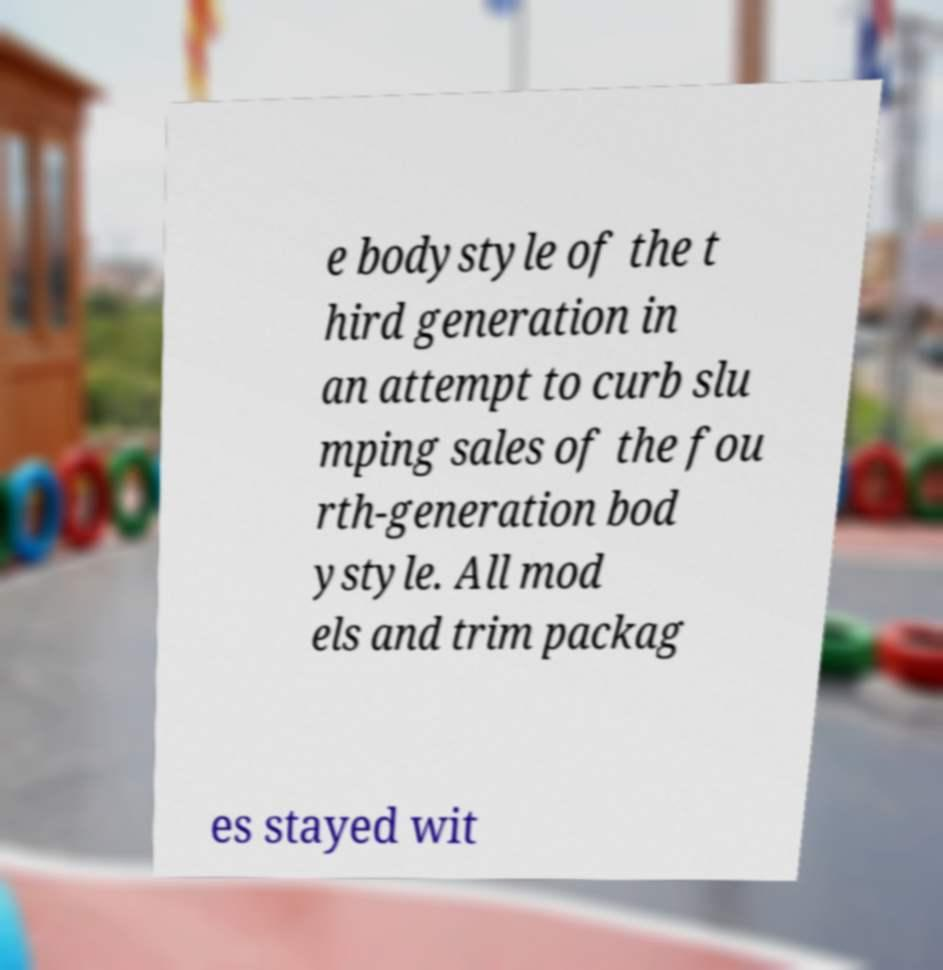Can you accurately transcribe the text from the provided image for me? e bodystyle of the t hird generation in an attempt to curb slu mping sales of the fou rth-generation bod ystyle. All mod els and trim packag es stayed wit 